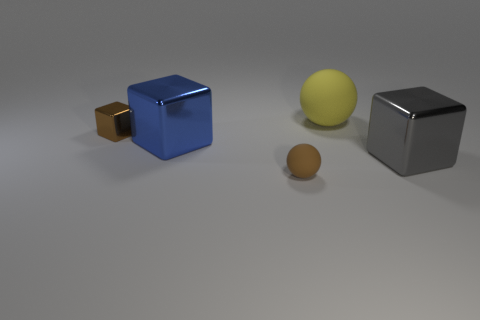Does the small shiny object have the same color as the big metallic cube right of the blue metallic block? No, the small shiny object exhibits a brown hue, distinguishing itself from the big metallic cube to the right of the blue block, which has a distinct silver color. 